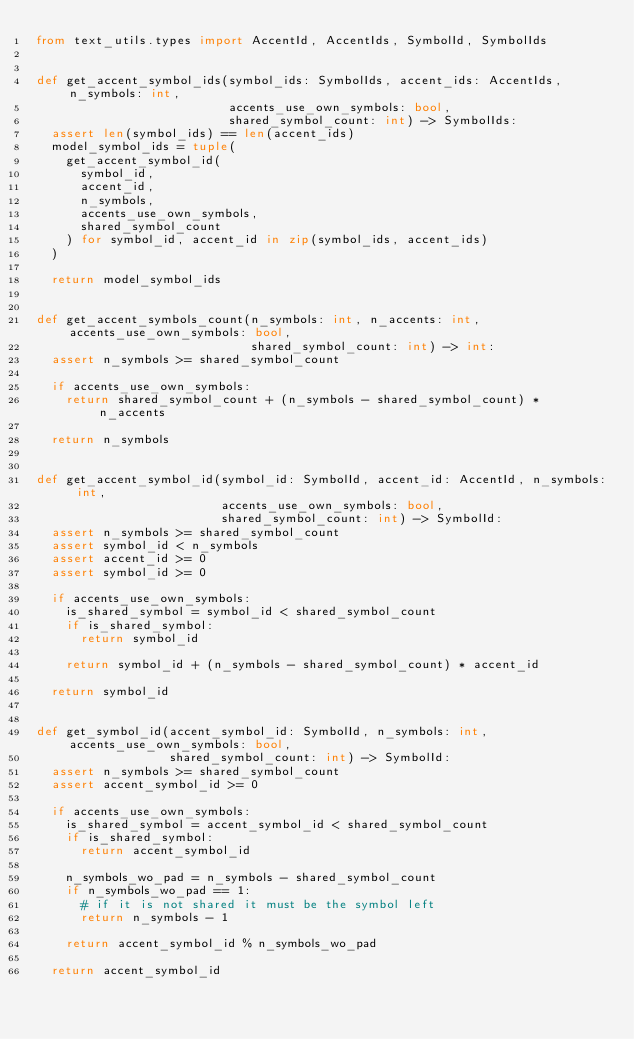Convert code to text. <code><loc_0><loc_0><loc_500><loc_500><_Python_>from text_utils.types import AccentId, AccentIds, SymbolId, SymbolIds


def get_accent_symbol_ids(symbol_ids: SymbolIds, accent_ids: AccentIds, n_symbols: int,
                          accents_use_own_symbols: bool,
                          shared_symbol_count: int) -> SymbolIds:
  assert len(symbol_ids) == len(accent_ids)
  model_symbol_ids = tuple(
    get_accent_symbol_id(
      symbol_id,
      accent_id,
      n_symbols,
      accents_use_own_symbols,
      shared_symbol_count
    ) for symbol_id, accent_id in zip(symbol_ids, accent_ids)
  )

  return model_symbol_ids


def get_accent_symbols_count(n_symbols: int, n_accents: int, accents_use_own_symbols: bool,
                             shared_symbol_count: int) -> int:
  assert n_symbols >= shared_symbol_count

  if accents_use_own_symbols:
    return shared_symbol_count + (n_symbols - shared_symbol_count) * n_accents

  return n_symbols


def get_accent_symbol_id(symbol_id: SymbolId, accent_id: AccentId, n_symbols: int,
                         accents_use_own_symbols: bool,
                         shared_symbol_count: int) -> SymbolId:
  assert n_symbols >= shared_symbol_count
  assert symbol_id < n_symbols
  assert accent_id >= 0
  assert symbol_id >= 0

  if accents_use_own_symbols:
    is_shared_symbol = symbol_id < shared_symbol_count
    if is_shared_symbol:
      return symbol_id

    return symbol_id + (n_symbols - shared_symbol_count) * accent_id

  return symbol_id


def get_symbol_id(accent_symbol_id: SymbolId, n_symbols: int, accents_use_own_symbols: bool,
                  shared_symbol_count: int) -> SymbolId:
  assert n_symbols >= shared_symbol_count
  assert accent_symbol_id >= 0

  if accents_use_own_symbols:
    is_shared_symbol = accent_symbol_id < shared_symbol_count
    if is_shared_symbol:
      return accent_symbol_id

    n_symbols_wo_pad = n_symbols - shared_symbol_count
    if n_symbols_wo_pad == 1:
      # if it is not shared it must be the symbol left
      return n_symbols - 1

    return accent_symbol_id % n_symbols_wo_pad

  return accent_symbol_id
</code> 